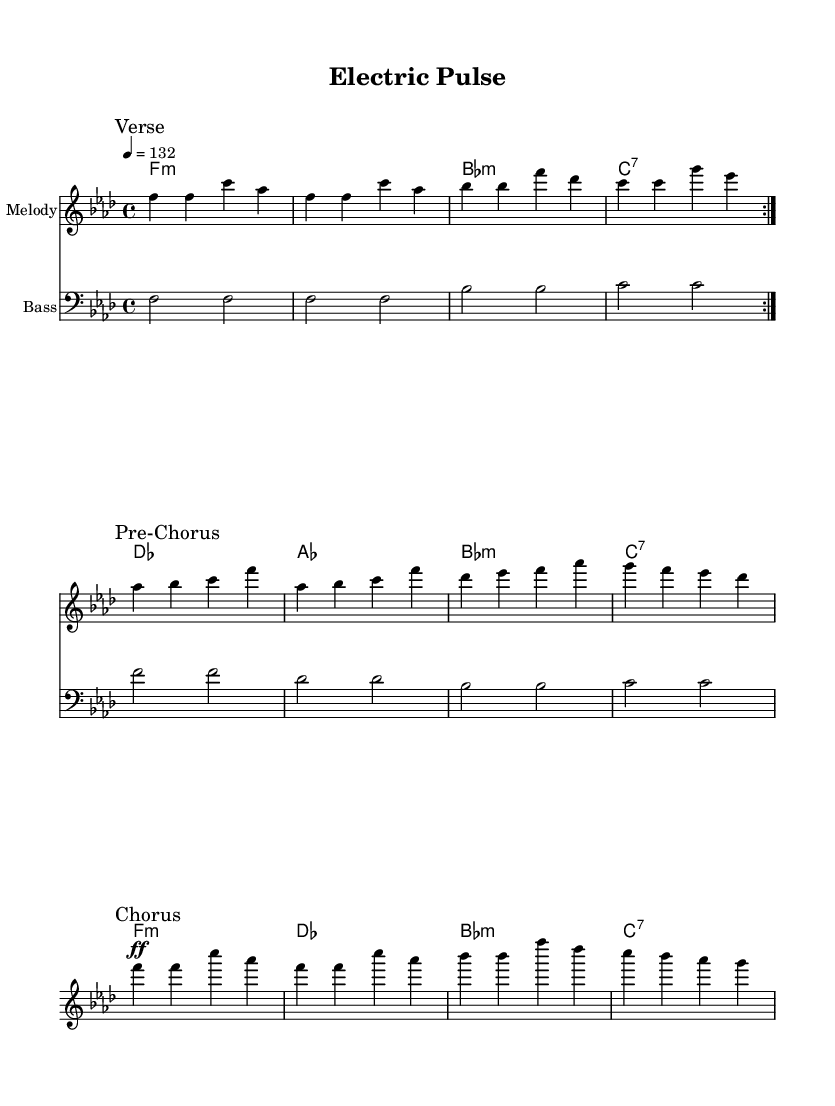What is the key signature of this music? The key signature is F minor, which has four flats (B♭, E♭, A♭, D♭). This can be identified from the beginning of the score where the key is indicated.
Answer: F minor What is the time signature of this music? The time signature is 4/4, as noted at the beginning of the score. This means there are four beats in each measure and the quarter note gets one beat.
Answer: 4/4 What is the tempo marking of the piece? The tempo marking is 132 beats per minute, as indicated by the "4 = 132" notation. This shows the speed of the music.
Answer: 132 How many sections are in the music? The music consists of three distinct sections: Verse, Pre-Chorus, and Chorus. Each section is labeled with a mark in the sheet music, indicating the structure of the song.
Answer: 3 What is the dynamic marking for the chorus? The dynamic marking for the chorus is fortissimo (ff), indicating it should be played very loudly. This can be seen in the score where "ff" is placed above the corresponding notes in the chorus section.
Answer: fortissimo Which musical elements are emphasized in K-Pop tracks like this one? K-Pop tracks often emphasize intricate dance breaks and electronic drops, which can usually be seen through strong rhythmic support and dynamic contrasts in the music. In this piece, these elements can be identified by the varied dynamics and energetic tempo.
Answer: dance breaks and electronic drops 